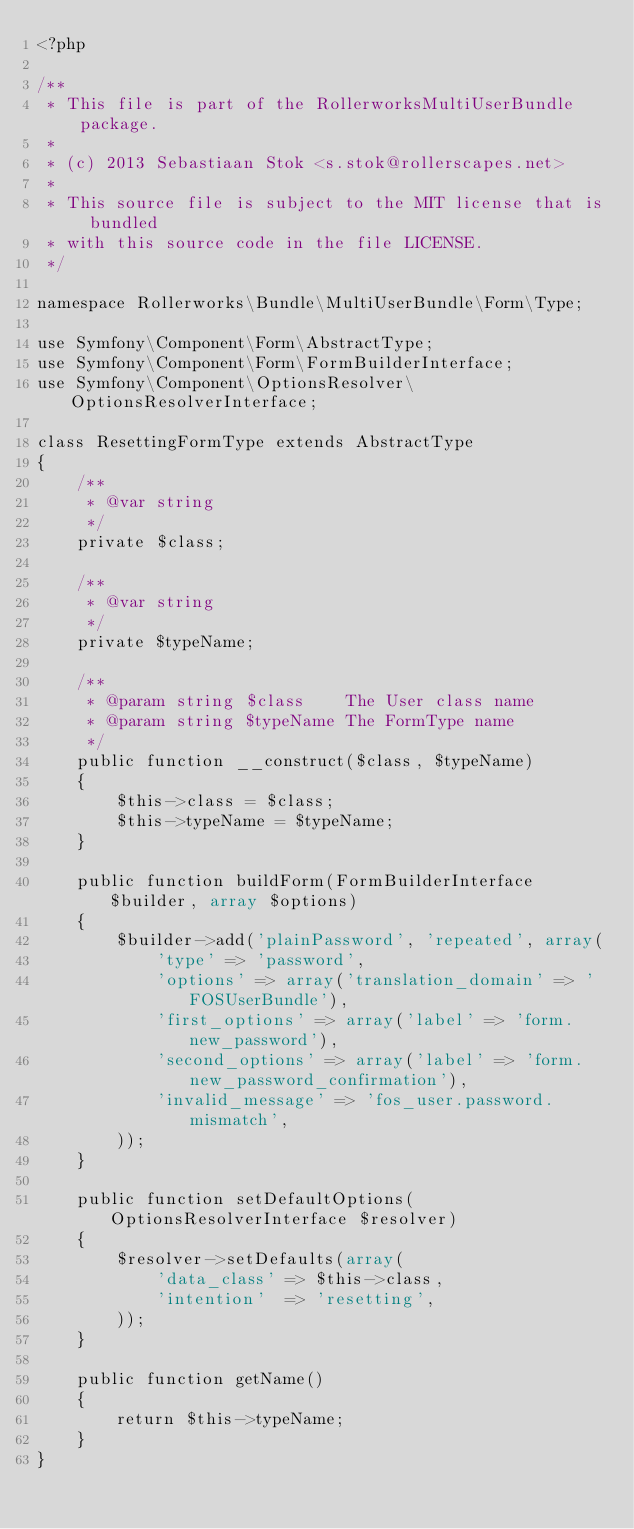<code> <loc_0><loc_0><loc_500><loc_500><_PHP_><?php

/**
 * This file is part of the RollerworksMultiUserBundle package.
 *
 * (c) 2013 Sebastiaan Stok <s.stok@rollerscapes.net>
 *
 * This source file is subject to the MIT license that is bundled
 * with this source code in the file LICENSE.
 */

namespace Rollerworks\Bundle\MultiUserBundle\Form\Type;

use Symfony\Component\Form\AbstractType;
use Symfony\Component\Form\FormBuilderInterface;
use Symfony\Component\OptionsResolver\OptionsResolverInterface;

class ResettingFormType extends AbstractType
{
    /**
     * @var string
     */
    private $class;

    /**
     * @var string
     */
    private $typeName;

    /**
     * @param string $class    The User class name
     * @param string $typeName The FormType name
     */
    public function __construct($class, $typeName)
    {
        $this->class = $class;
        $this->typeName = $typeName;
    }

    public function buildForm(FormBuilderInterface $builder, array $options)
    {
        $builder->add('plainPassword', 'repeated', array(
            'type' => 'password',
            'options' => array('translation_domain' => 'FOSUserBundle'),
            'first_options' => array('label' => 'form.new_password'),
            'second_options' => array('label' => 'form.new_password_confirmation'),
            'invalid_message' => 'fos_user.password.mismatch',
        ));
    }

    public function setDefaultOptions(OptionsResolverInterface $resolver)
    {
        $resolver->setDefaults(array(
            'data_class' => $this->class,
            'intention'  => 'resetting',
        ));
    }

    public function getName()
    {
        return $this->typeName;
    }
}
</code> 